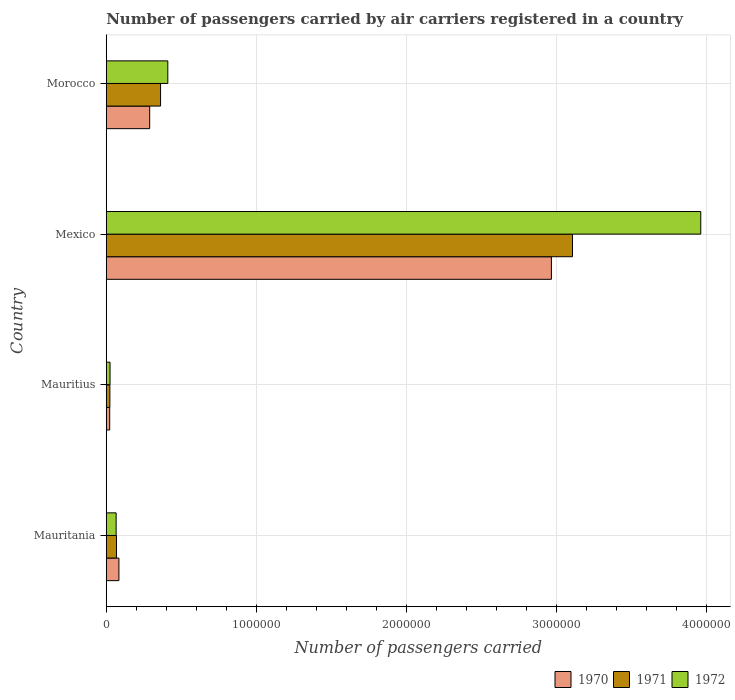How many different coloured bars are there?
Your response must be concise. 3. How many groups of bars are there?
Keep it short and to the point. 4. Are the number of bars per tick equal to the number of legend labels?
Provide a succinct answer. Yes. How many bars are there on the 1st tick from the top?
Your answer should be compact. 3. How many bars are there on the 4th tick from the bottom?
Give a very brief answer. 3. What is the label of the 1st group of bars from the top?
Your answer should be compact. Morocco. In how many cases, is the number of bars for a given country not equal to the number of legend labels?
Your answer should be compact. 0. What is the number of passengers carried by air carriers in 1970 in Morocco?
Make the answer very short. 2.90e+05. Across all countries, what is the maximum number of passengers carried by air carriers in 1970?
Your answer should be very brief. 2.97e+06. Across all countries, what is the minimum number of passengers carried by air carriers in 1972?
Your response must be concise. 2.52e+04. In which country was the number of passengers carried by air carriers in 1972 minimum?
Provide a succinct answer. Mauritius. What is the total number of passengers carried by air carriers in 1970 in the graph?
Your answer should be compact. 3.36e+06. What is the difference between the number of passengers carried by air carriers in 1972 in Mauritania and that in Morocco?
Make the answer very short. -3.44e+05. What is the difference between the number of passengers carried by air carriers in 1972 in Mauritania and the number of passengers carried by air carriers in 1970 in Mexico?
Provide a short and direct response. -2.90e+06. What is the average number of passengers carried by air carriers in 1972 per country?
Offer a very short reply. 1.12e+06. What is the difference between the number of passengers carried by air carriers in 1972 and number of passengers carried by air carriers in 1971 in Mauritius?
Your response must be concise. 1000. What is the ratio of the number of passengers carried by air carriers in 1972 in Mexico to that in Morocco?
Provide a short and direct response. 9.66. What is the difference between the highest and the second highest number of passengers carried by air carriers in 1972?
Provide a succinct answer. 3.55e+06. What is the difference between the highest and the lowest number of passengers carried by air carriers in 1971?
Provide a short and direct response. 3.08e+06. In how many countries, is the number of passengers carried by air carriers in 1972 greater than the average number of passengers carried by air carriers in 1972 taken over all countries?
Keep it short and to the point. 1. What does the 3rd bar from the top in Morocco represents?
Make the answer very short. 1970. How many countries are there in the graph?
Make the answer very short. 4. Are the values on the major ticks of X-axis written in scientific E-notation?
Your response must be concise. No. Where does the legend appear in the graph?
Your response must be concise. Bottom right. How many legend labels are there?
Keep it short and to the point. 3. How are the legend labels stacked?
Give a very brief answer. Horizontal. What is the title of the graph?
Provide a short and direct response. Number of passengers carried by air carriers registered in a country. What is the label or title of the X-axis?
Give a very brief answer. Number of passengers carried. What is the label or title of the Y-axis?
Provide a short and direct response. Country. What is the Number of passengers carried of 1970 in Mauritania?
Provide a succinct answer. 8.45e+04. What is the Number of passengers carried in 1971 in Mauritania?
Your response must be concise. 6.84e+04. What is the Number of passengers carried of 1972 in Mauritania?
Make the answer very short. 6.59e+04. What is the Number of passengers carried of 1970 in Mauritius?
Provide a short and direct response. 2.30e+04. What is the Number of passengers carried of 1971 in Mauritius?
Offer a terse response. 2.42e+04. What is the Number of passengers carried in 1972 in Mauritius?
Your response must be concise. 2.52e+04. What is the Number of passengers carried of 1970 in Mexico?
Your answer should be very brief. 2.97e+06. What is the Number of passengers carried in 1971 in Mexico?
Your answer should be very brief. 3.11e+06. What is the Number of passengers carried in 1972 in Mexico?
Your answer should be very brief. 3.96e+06. What is the Number of passengers carried of 1970 in Morocco?
Keep it short and to the point. 2.90e+05. What is the Number of passengers carried in 1971 in Morocco?
Provide a succinct answer. 3.62e+05. What is the Number of passengers carried of 1972 in Morocco?
Provide a short and direct response. 4.10e+05. Across all countries, what is the maximum Number of passengers carried in 1970?
Your response must be concise. 2.97e+06. Across all countries, what is the maximum Number of passengers carried of 1971?
Offer a terse response. 3.11e+06. Across all countries, what is the maximum Number of passengers carried of 1972?
Provide a succinct answer. 3.96e+06. Across all countries, what is the minimum Number of passengers carried of 1970?
Offer a very short reply. 2.30e+04. Across all countries, what is the minimum Number of passengers carried in 1971?
Your response must be concise. 2.42e+04. Across all countries, what is the minimum Number of passengers carried of 1972?
Provide a succinct answer. 2.52e+04. What is the total Number of passengers carried of 1970 in the graph?
Offer a terse response. 3.36e+06. What is the total Number of passengers carried in 1971 in the graph?
Ensure brevity in your answer.  3.56e+06. What is the total Number of passengers carried in 1972 in the graph?
Your answer should be compact. 4.46e+06. What is the difference between the Number of passengers carried in 1970 in Mauritania and that in Mauritius?
Keep it short and to the point. 6.15e+04. What is the difference between the Number of passengers carried in 1971 in Mauritania and that in Mauritius?
Your answer should be compact. 4.42e+04. What is the difference between the Number of passengers carried in 1972 in Mauritania and that in Mauritius?
Your answer should be compact. 4.07e+04. What is the difference between the Number of passengers carried of 1970 in Mauritania and that in Mexico?
Keep it short and to the point. -2.88e+06. What is the difference between the Number of passengers carried of 1971 in Mauritania and that in Mexico?
Provide a short and direct response. -3.04e+06. What is the difference between the Number of passengers carried in 1972 in Mauritania and that in Mexico?
Offer a terse response. -3.90e+06. What is the difference between the Number of passengers carried of 1970 in Mauritania and that in Morocco?
Your answer should be compact. -2.05e+05. What is the difference between the Number of passengers carried in 1971 in Mauritania and that in Morocco?
Ensure brevity in your answer.  -2.94e+05. What is the difference between the Number of passengers carried of 1972 in Mauritania and that in Morocco?
Offer a terse response. -3.44e+05. What is the difference between the Number of passengers carried in 1970 in Mauritius and that in Mexico?
Provide a succinct answer. -2.94e+06. What is the difference between the Number of passengers carried in 1971 in Mauritius and that in Mexico?
Give a very brief answer. -3.08e+06. What is the difference between the Number of passengers carried in 1972 in Mauritius and that in Mexico?
Offer a very short reply. -3.94e+06. What is the difference between the Number of passengers carried of 1970 in Mauritius and that in Morocco?
Provide a short and direct response. -2.66e+05. What is the difference between the Number of passengers carried of 1971 in Mauritius and that in Morocco?
Your answer should be compact. -3.38e+05. What is the difference between the Number of passengers carried of 1972 in Mauritius and that in Morocco?
Provide a succinct answer. -3.85e+05. What is the difference between the Number of passengers carried of 1970 in Mexico and that in Morocco?
Offer a terse response. 2.68e+06. What is the difference between the Number of passengers carried in 1971 in Mexico and that in Morocco?
Your answer should be very brief. 2.75e+06. What is the difference between the Number of passengers carried in 1972 in Mexico and that in Morocco?
Offer a terse response. 3.55e+06. What is the difference between the Number of passengers carried in 1970 in Mauritania and the Number of passengers carried in 1971 in Mauritius?
Ensure brevity in your answer.  6.03e+04. What is the difference between the Number of passengers carried in 1970 in Mauritania and the Number of passengers carried in 1972 in Mauritius?
Ensure brevity in your answer.  5.93e+04. What is the difference between the Number of passengers carried of 1971 in Mauritania and the Number of passengers carried of 1972 in Mauritius?
Give a very brief answer. 4.32e+04. What is the difference between the Number of passengers carried of 1970 in Mauritania and the Number of passengers carried of 1971 in Mexico?
Provide a succinct answer. -3.02e+06. What is the difference between the Number of passengers carried of 1970 in Mauritania and the Number of passengers carried of 1972 in Mexico?
Ensure brevity in your answer.  -3.88e+06. What is the difference between the Number of passengers carried of 1971 in Mauritania and the Number of passengers carried of 1972 in Mexico?
Provide a short and direct response. -3.89e+06. What is the difference between the Number of passengers carried of 1970 in Mauritania and the Number of passengers carried of 1971 in Morocco?
Offer a terse response. -2.78e+05. What is the difference between the Number of passengers carried of 1970 in Mauritania and the Number of passengers carried of 1972 in Morocco?
Your answer should be compact. -3.26e+05. What is the difference between the Number of passengers carried in 1971 in Mauritania and the Number of passengers carried in 1972 in Morocco?
Your answer should be compact. -3.42e+05. What is the difference between the Number of passengers carried in 1970 in Mauritius and the Number of passengers carried in 1971 in Mexico?
Ensure brevity in your answer.  -3.08e+06. What is the difference between the Number of passengers carried of 1970 in Mauritius and the Number of passengers carried of 1972 in Mexico?
Keep it short and to the point. -3.94e+06. What is the difference between the Number of passengers carried in 1971 in Mauritius and the Number of passengers carried in 1972 in Mexico?
Ensure brevity in your answer.  -3.94e+06. What is the difference between the Number of passengers carried of 1970 in Mauritius and the Number of passengers carried of 1971 in Morocco?
Keep it short and to the point. -3.39e+05. What is the difference between the Number of passengers carried in 1970 in Mauritius and the Number of passengers carried in 1972 in Morocco?
Offer a terse response. -3.87e+05. What is the difference between the Number of passengers carried of 1971 in Mauritius and the Number of passengers carried of 1972 in Morocco?
Offer a terse response. -3.86e+05. What is the difference between the Number of passengers carried in 1970 in Mexico and the Number of passengers carried in 1971 in Morocco?
Your answer should be very brief. 2.60e+06. What is the difference between the Number of passengers carried in 1970 in Mexico and the Number of passengers carried in 1972 in Morocco?
Your response must be concise. 2.56e+06. What is the difference between the Number of passengers carried in 1971 in Mexico and the Number of passengers carried in 1972 in Morocco?
Provide a succinct answer. 2.70e+06. What is the average Number of passengers carried in 1970 per country?
Provide a short and direct response. 8.41e+05. What is the average Number of passengers carried of 1971 per country?
Keep it short and to the point. 8.90e+05. What is the average Number of passengers carried in 1972 per country?
Offer a terse response. 1.12e+06. What is the difference between the Number of passengers carried in 1970 and Number of passengers carried in 1971 in Mauritania?
Make the answer very short. 1.61e+04. What is the difference between the Number of passengers carried in 1970 and Number of passengers carried in 1972 in Mauritania?
Keep it short and to the point. 1.86e+04. What is the difference between the Number of passengers carried in 1971 and Number of passengers carried in 1972 in Mauritania?
Make the answer very short. 2500. What is the difference between the Number of passengers carried in 1970 and Number of passengers carried in 1971 in Mauritius?
Give a very brief answer. -1200. What is the difference between the Number of passengers carried in 1970 and Number of passengers carried in 1972 in Mauritius?
Make the answer very short. -2200. What is the difference between the Number of passengers carried in 1971 and Number of passengers carried in 1972 in Mauritius?
Make the answer very short. -1000. What is the difference between the Number of passengers carried in 1970 and Number of passengers carried in 1971 in Mexico?
Make the answer very short. -1.41e+05. What is the difference between the Number of passengers carried in 1970 and Number of passengers carried in 1972 in Mexico?
Offer a very short reply. -9.95e+05. What is the difference between the Number of passengers carried of 1971 and Number of passengers carried of 1972 in Mexico?
Provide a succinct answer. -8.55e+05. What is the difference between the Number of passengers carried in 1970 and Number of passengers carried in 1971 in Morocco?
Ensure brevity in your answer.  -7.25e+04. What is the difference between the Number of passengers carried in 1970 and Number of passengers carried in 1972 in Morocco?
Offer a terse response. -1.21e+05. What is the difference between the Number of passengers carried in 1971 and Number of passengers carried in 1972 in Morocco?
Give a very brief answer. -4.83e+04. What is the ratio of the Number of passengers carried of 1970 in Mauritania to that in Mauritius?
Provide a short and direct response. 3.67. What is the ratio of the Number of passengers carried in 1971 in Mauritania to that in Mauritius?
Your response must be concise. 2.83. What is the ratio of the Number of passengers carried in 1972 in Mauritania to that in Mauritius?
Give a very brief answer. 2.62. What is the ratio of the Number of passengers carried of 1970 in Mauritania to that in Mexico?
Offer a very short reply. 0.03. What is the ratio of the Number of passengers carried in 1971 in Mauritania to that in Mexico?
Provide a succinct answer. 0.02. What is the ratio of the Number of passengers carried of 1972 in Mauritania to that in Mexico?
Your answer should be very brief. 0.02. What is the ratio of the Number of passengers carried of 1970 in Mauritania to that in Morocco?
Offer a very short reply. 0.29. What is the ratio of the Number of passengers carried in 1971 in Mauritania to that in Morocco?
Your answer should be very brief. 0.19. What is the ratio of the Number of passengers carried in 1972 in Mauritania to that in Morocco?
Your response must be concise. 0.16. What is the ratio of the Number of passengers carried of 1970 in Mauritius to that in Mexico?
Make the answer very short. 0.01. What is the ratio of the Number of passengers carried of 1971 in Mauritius to that in Mexico?
Offer a very short reply. 0.01. What is the ratio of the Number of passengers carried of 1972 in Mauritius to that in Mexico?
Your answer should be compact. 0.01. What is the ratio of the Number of passengers carried in 1970 in Mauritius to that in Morocco?
Make the answer very short. 0.08. What is the ratio of the Number of passengers carried of 1971 in Mauritius to that in Morocco?
Offer a very short reply. 0.07. What is the ratio of the Number of passengers carried in 1972 in Mauritius to that in Morocco?
Your answer should be compact. 0.06. What is the ratio of the Number of passengers carried of 1970 in Mexico to that in Morocco?
Your response must be concise. 10.25. What is the ratio of the Number of passengers carried in 1971 in Mexico to that in Morocco?
Your response must be concise. 8.58. What is the ratio of the Number of passengers carried of 1972 in Mexico to that in Morocco?
Provide a succinct answer. 9.66. What is the difference between the highest and the second highest Number of passengers carried in 1970?
Ensure brevity in your answer.  2.68e+06. What is the difference between the highest and the second highest Number of passengers carried in 1971?
Provide a succinct answer. 2.75e+06. What is the difference between the highest and the second highest Number of passengers carried in 1972?
Your answer should be compact. 3.55e+06. What is the difference between the highest and the lowest Number of passengers carried in 1970?
Keep it short and to the point. 2.94e+06. What is the difference between the highest and the lowest Number of passengers carried of 1971?
Offer a very short reply. 3.08e+06. What is the difference between the highest and the lowest Number of passengers carried in 1972?
Ensure brevity in your answer.  3.94e+06. 